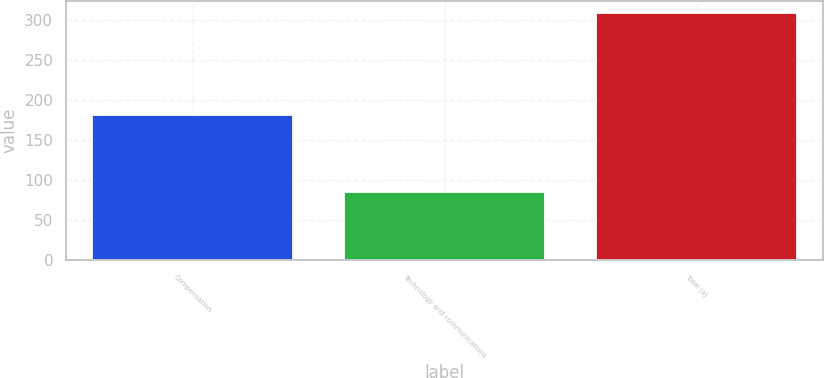<chart> <loc_0><loc_0><loc_500><loc_500><bar_chart><fcel>Compensation<fcel>Technology and communications<fcel>Total (a)<nl><fcel>181<fcel>85<fcel>308<nl></chart> 